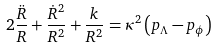Convert formula to latex. <formula><loc_0><loc_0><loc_500><loc_500>2 \frac { \ddot { R } } { R } + \frac { \dot { R } ^ { 2 } } { R ^ { 2 } } + \frac { k } { R ^ { 2 } } = \kappa ^ { 2 } \left ( p _ { \Lambda } - p _ { \phi } \right )</formula> 